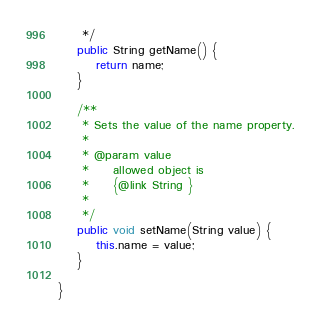Convert code to text. <code><loc_0><loc_0><loc_500><loc_500><_Java_>     */
    public String getName() {
        return name;
    }

    /**
     * Sets the value of the name property.
     * 
     * @param value
     *     allowed object is
     *     {@link String }
     *     
     */
    public void setName(String value) {
        this.name = value;
    }

}
</code> 